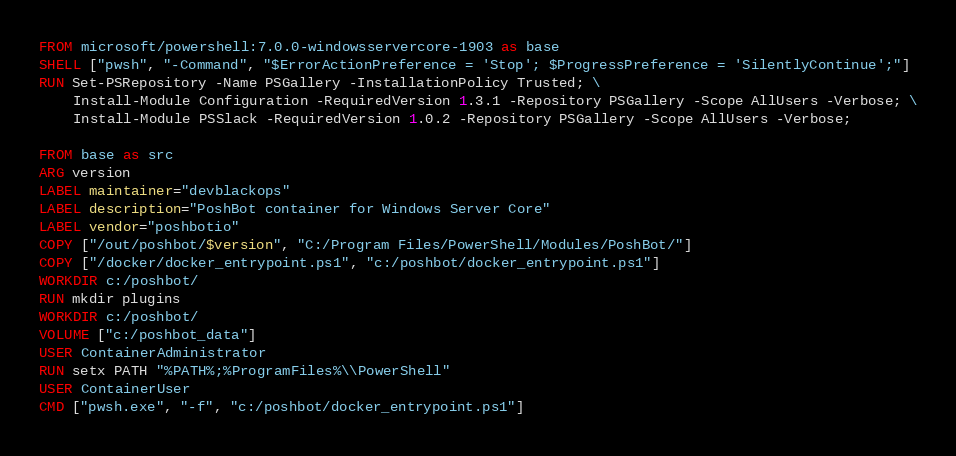Convert code to text. <code><loc_0><loc_0><loc_500><loc_500><_Dockerfile_>FROM microsoft/powershell:7.0.0-windowsservercore-1903 as base
SHELL ["pwsh", "-Command", "$ErrorActionPreference = 'Stop'; $ProgressPreference = 'SilentlyContinue';"]
RUN Set-PSRepository -Name PSGallery -InstallationPolicy Trusted; \
    Install-Module Configuration -RequiredVersion 1.3.1 -Repository PSGallery -Scope AllUsers -Verbose; \
    Install-Module PSSlack -RequiredVersion 1.0.2 -Repository PSGallery -Scope AllUsers -Verbose;

FROM base as src
ARG version
LABEL maintainer="devblackops"
LABEL description="PoshBot container for Windows Server Core"
LABEL vendor="poshbotio"
COPY ["/out/poshbot/$version", "C:/Program Files/PowerShell/Modules/PoshBot/"]
COPY ["/docker/docker_entrypoint.ps1", "c:/poshbot/docker_entrypoint.ps1"]
WORKDIR c:/poshbot/
RUN mkdir plugins
WORKDIR c:/poshbot/
VOLUME ["c:/poshbot_data"]
USER ContainerAdministrator
RUN setx PATH "%PATH%;%ProgramFiles%\\PowerShell"
USER ContainerUser
CMD ["pwsh.exe", "-f", "c:/poshbot/docker_entrypoint.ps1"]
</code> 